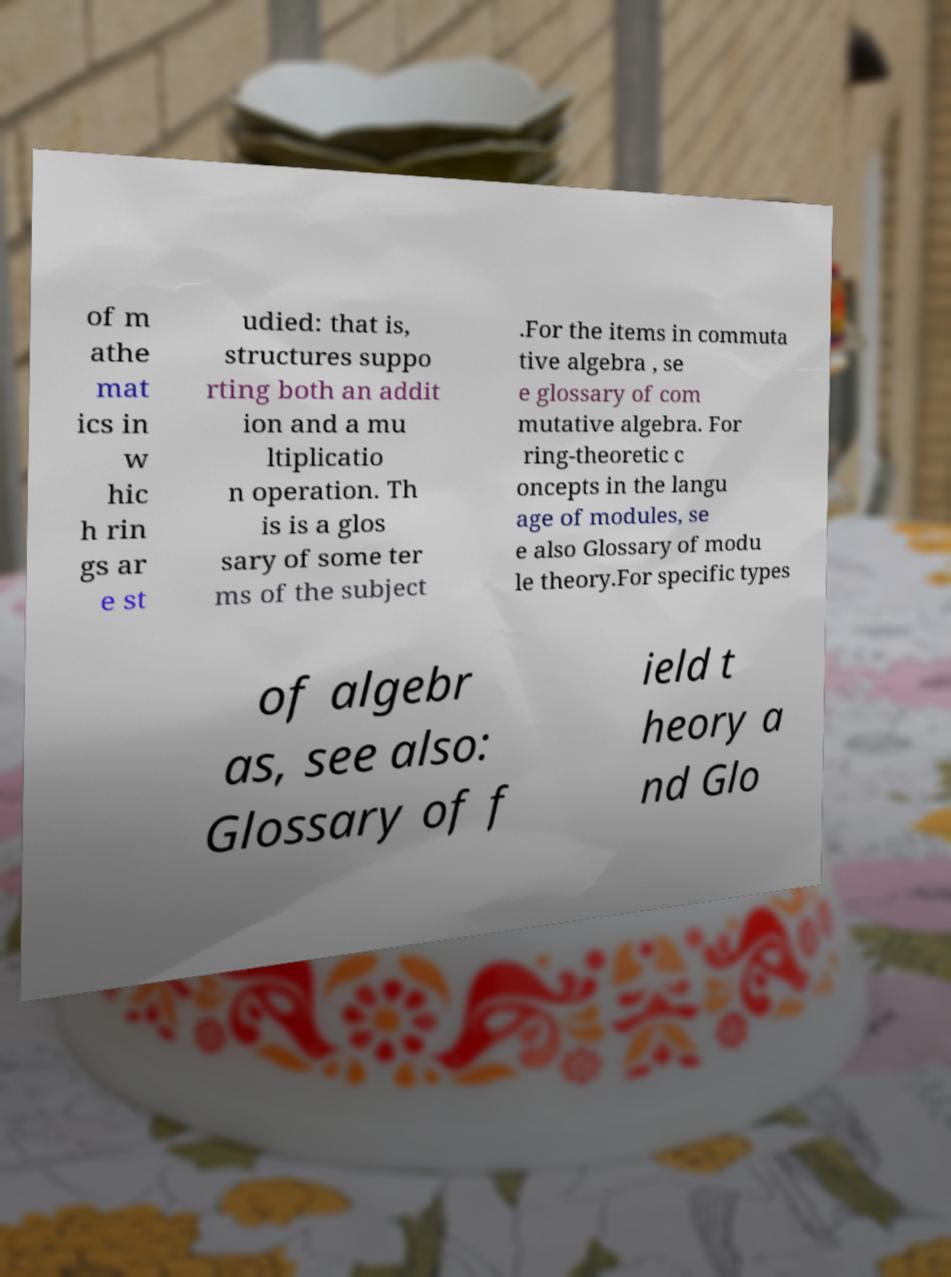For documentation purposes, I need the text within this image transcribed. Could you provide that? of m athe mat ics in w hic h rin gs ar e st udied: that is, structures suppo rting both an addit ion and a mu ltiplicatio n operation. Th is is a glos sary of some ter ms of the subject .For the items in commuta tive algebra , se e glossary of com mutative algebra. For ring-theoretic c oncepts in the langu age of modules, se e also Glossary of modu le theory.For specific types of algebr as, see also: Glossary of f ield t heory a nd Glo 